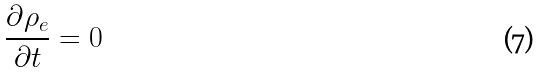<formula> <loc_0><loc_0><loc_500><loc_500>\frac { \partial \rho _ { e } } { \partial t } = 0</formula> 